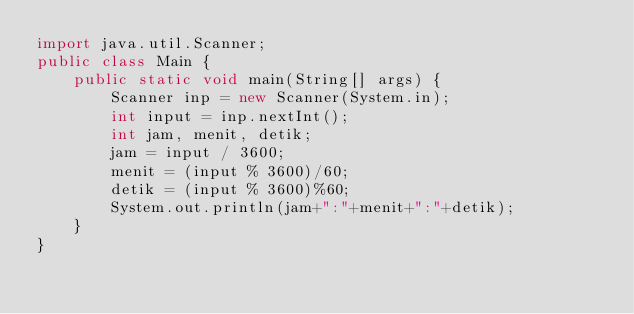Convert code to text. <code><loc_0><loc_0><loc_500><loc_500><_Java_>import java.util.Scanner;
public class Main {
    public static void main(String[] args) {
        Scanner inp = new Scanner(System.in);
        int input = inp.nextInt();
        int jam, menit, detik;
        jam = input / 3600;
        menit = (input % 3600)/60;
        detik = (input % 3600)%60;
        System.out.println(jam+":"+menit+":"+detik);
    }
}
</code> 